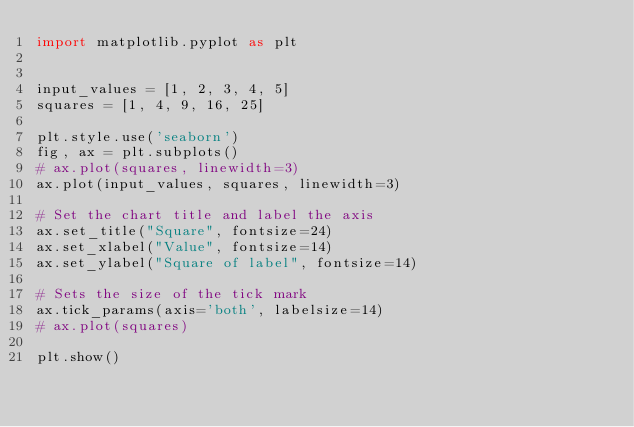Convert code to text. <code><loc_0><loc_0><loc_500><loc_500><_Python_>import matplotlib.pyplot as plt


input_values = [1, 2, 3, 4, 5]
squares = [1, 4, 9, 16, 25]

plt.style.use('seaborn')
fig, ax = plt.subplots()
# ax.plot(squares, linewidth=3)
ax.plot(input_values, squares, linewidth=3)

# Set the chart title and label the axis
ax.set_title("Square", fontsize=24)
ax.set_xlabel("Value", fontsize=14)
ax.set_ylabel("Square of label", fontsize=14)

# Sets the size of the tick mark
ax.tick_params(axis='both', labelsize=14)
# ax.plot(squares)

plt.show()
</code> 